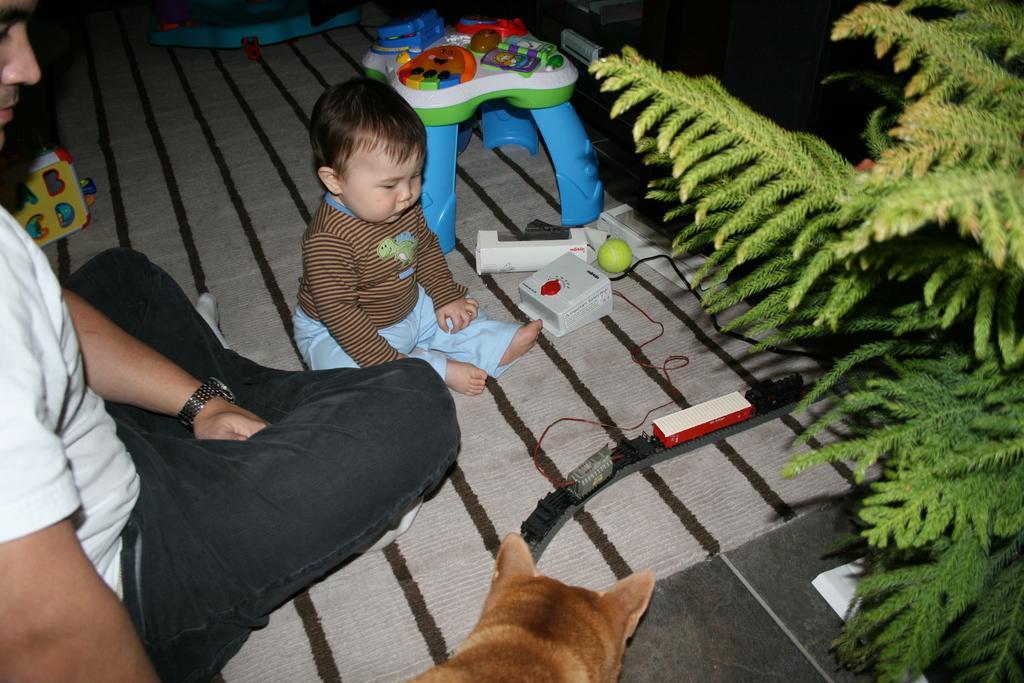Please provide a concise description of this image. As we can see in the image there is a man wearing white color t shirt, child, dog, toy, ball, stool and a tree. 